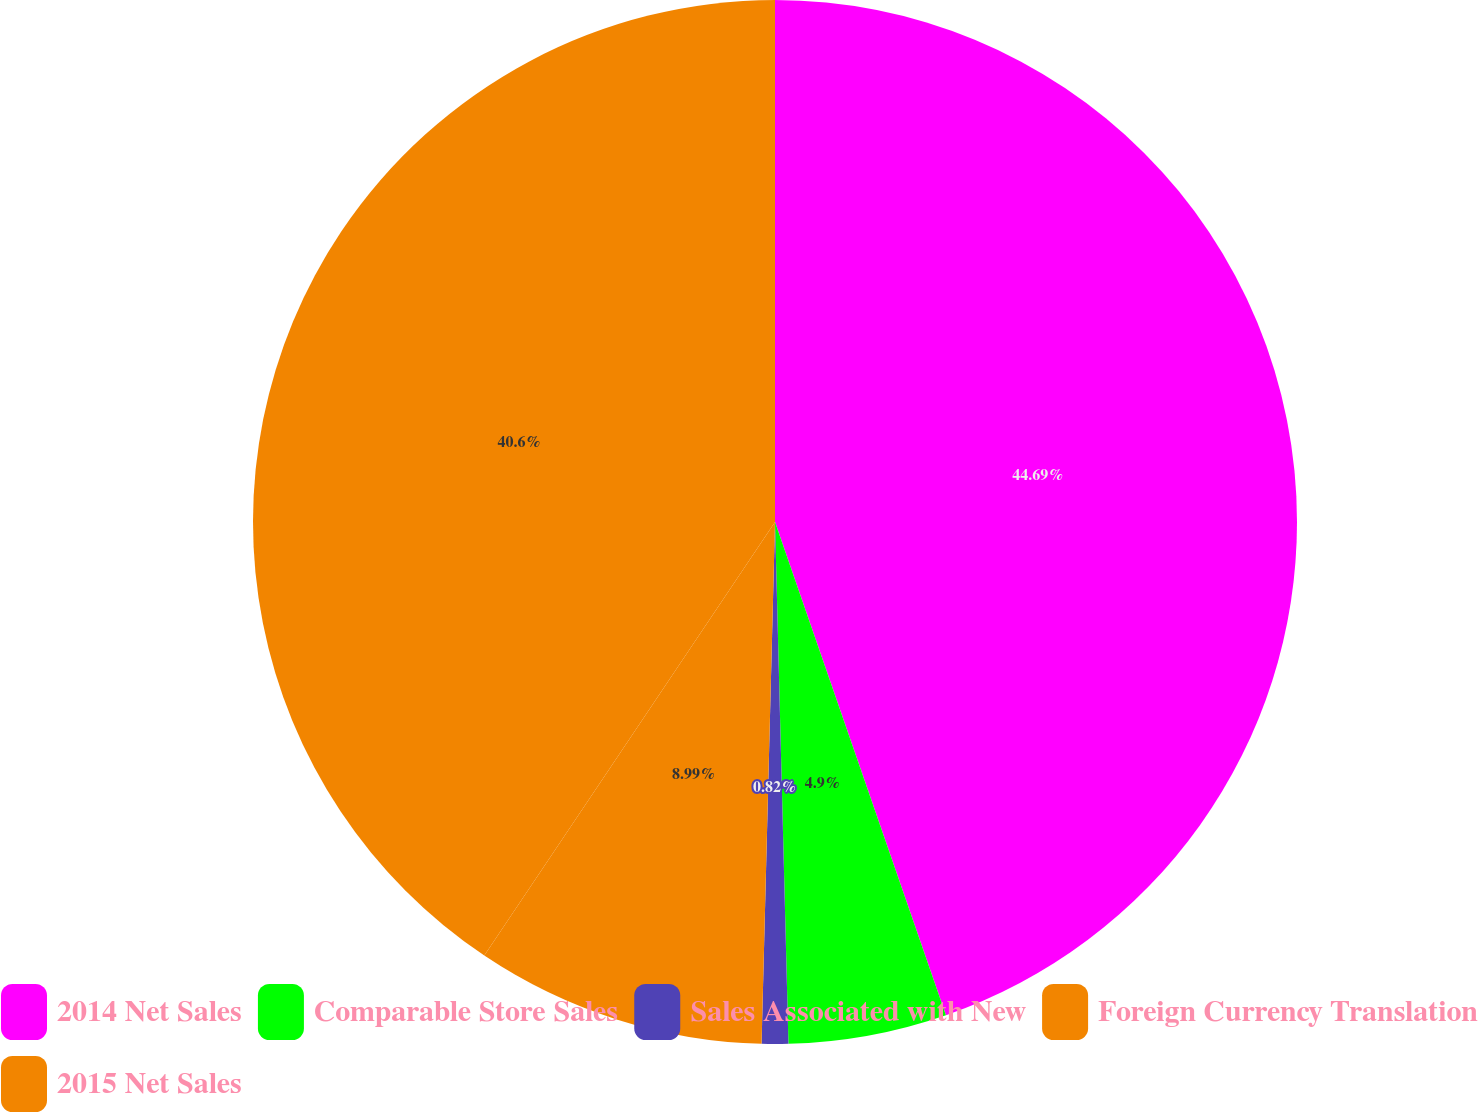Convert chart. <chart><loc_0><loc_0><loc_500><loc_500><pie_chart><fcel>2014 Net Sales<fcel>Comparable Store Sales<fcel>Sales Associated with New<fcel>Foreign Currency Translation<fcel>2015 Net Sales<nl><fcel>44.69%<fcel>4.9%<fcel>0.82%<fcel>8.99%<fcel>40.6%<nl></chart> 